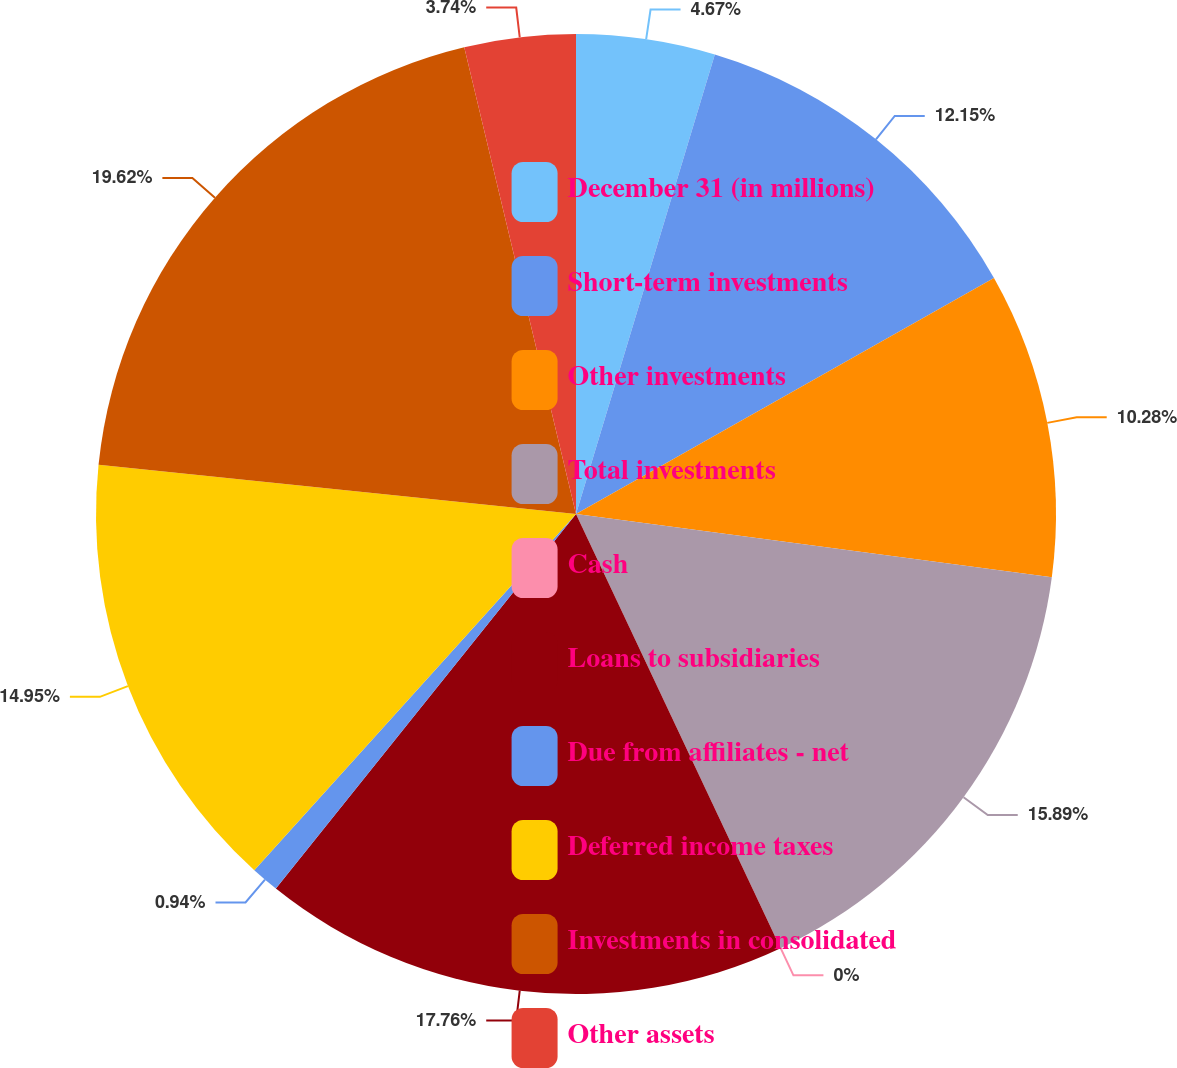<chart> <loc_0><loc_0><loc_500><loc_500><pie_chart><fcel>December 31 (in millions)<fcel>Short-term investments<fcel>Other investments<fcel>Total investments<fcel>Cash<fcel>Loans to subsidiaries<fcel>Due from affiliates - net<fcel>Deferred income taxes<fcel>Investments in consolidated<fcel>Other assets<nl><fcel>4.67%<fcel>12.15%<fcel>10.28%<fcel>15.89%<fcel>0.0%<fcel>17.76%<fcel>0.94%<fcel>14.95%<fcel>19.62%<fcel>3.74%<nl></chart> 